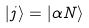Convert formula to latex. <formula><loc_0><loc_0><loc_500><loc_500>| j \rangle = | \alpha N \rangle</formula> 